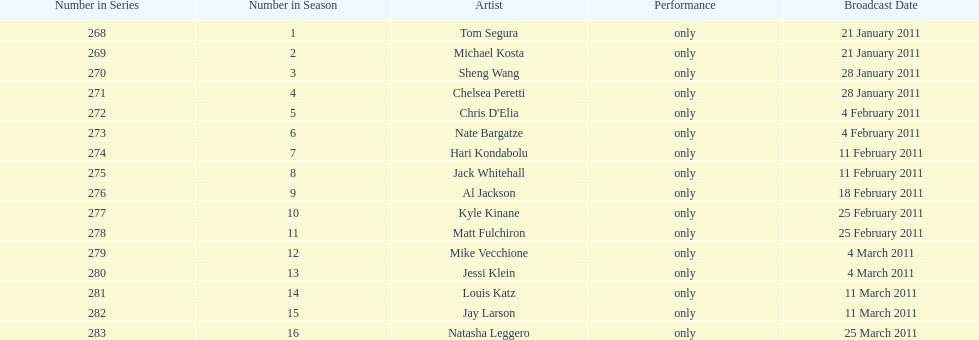What were the total number of air dates in february? 7. Write the full table. {'header': ['Number in Series', 'Number in Season', 'Artist', 'Performance', 'Broadcast Date'], 'rows': [['268', '1', 'Tom Segura', 'only', '21 January 2011'], ['269', '2', 'Michael Kosta', 'only', '21 January 2011'], ['270', '3', 'Sheng Wang', 'only', '28 January 2011'], ['271', '4', 'Chelsea Peretti', 'only', '28 January 2011'], ['272', '5', "Chris D'Elia", 'only', '4 February 2011'], ['273', '6', 'Nate Bargatze', 'only', '4 February 2011'], ['274', '7', 'Hari Kondabolu', 'only', '11 February 2011'], ['275', '8', 'Jack Whitehall', 'only', '11 February 2011'], ['276', '9', 'Al Jackson', 'only', '18 February 2011'], ['277', '10', 'Kyle Kinane', 'only', '25 February 2011'], ['278', '11', 'Matt Fulchiron', 'only', '25 February 2011'], ['279', '12', 'Mike Vecchione', 'only', '4 March 2011'], ['280', '13', 'Jessi Klein', 'only', '4 March 2011'], ['281', '14', 'Louis Katz', 'only', '11 March 2011'], ['282', '15', 'Jay Larson', 'only', '11 March 2011'], ['283', '16', 'Natasha Leggero', 'only', '25 March 2011']]} 